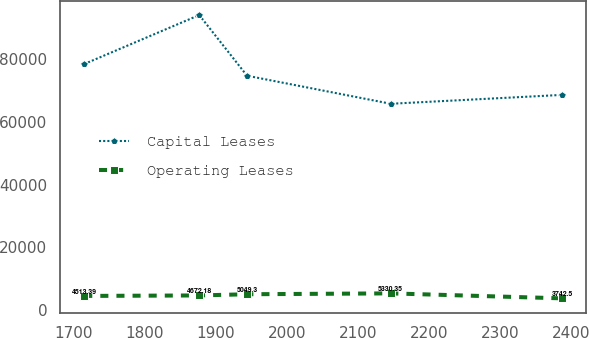Convert chart to OTSL. <chart><loc_0><loc_0><loc_500><loc_500><line_chart><ecel><fcel>Capital Leases<fcel>Operating Leases<nl><fcel>1714.71<fcel>78372.8<fcel>4513.39<nl><fcel>1876.67<fcel>93973.1<fcel>4672.18<nl><fcel>1943.92<fcel>74647.9<fcel>5049.3<nl><fcel>2146.21<fcel>65715.3<fcel>5330.35<nl><fcel>2387.19<fcel>68541.1<fcel>3742.5<nl></chart> 